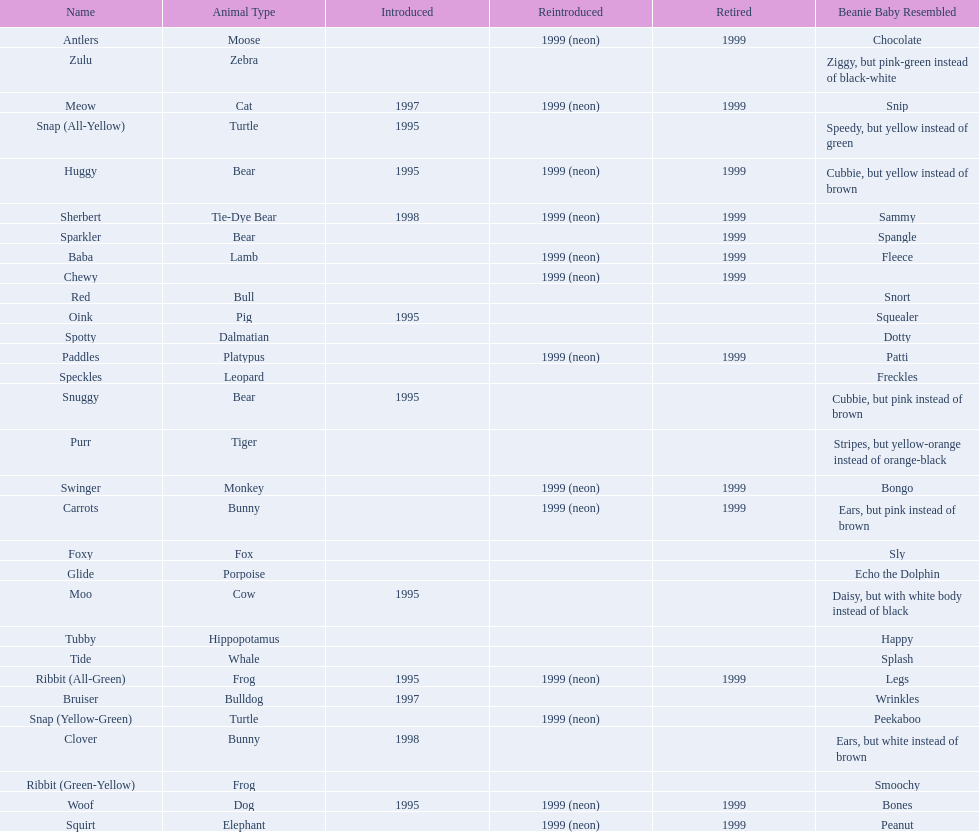What are all the different names of the pillow pals? Antlers, Baba, Bruiser, Carrots, Chewy, Clover, Foxy, Glide, Huggy, Meow, Moo, Oink, Paddles, Purr, Red, Ribbit (All-Green), Ribbit (Green-Yellow), Sherbert, Snap (All-Yellow), Snap (Yellow-Green), Snuggy, Sparkler, Speckles, Spotty, Squirt, Swinger, Tide, Tubby, Woof, Zulu. Which of these are a dalmatian? Spotty. 